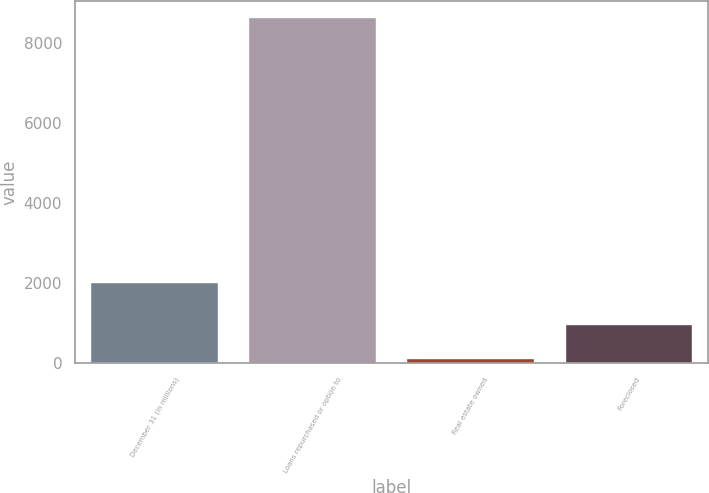<chart> <loc_0><loc_0><loc_500><loc_500><bar_chart><fcel>December 31 (in millions)<fcel>Loans repurchased or option to<fcel>Real estate owned<fcel>Foreclosed<nl><fcel>2017<fcel>8629<fcel>95<fcel>948.4<nl></chart> 